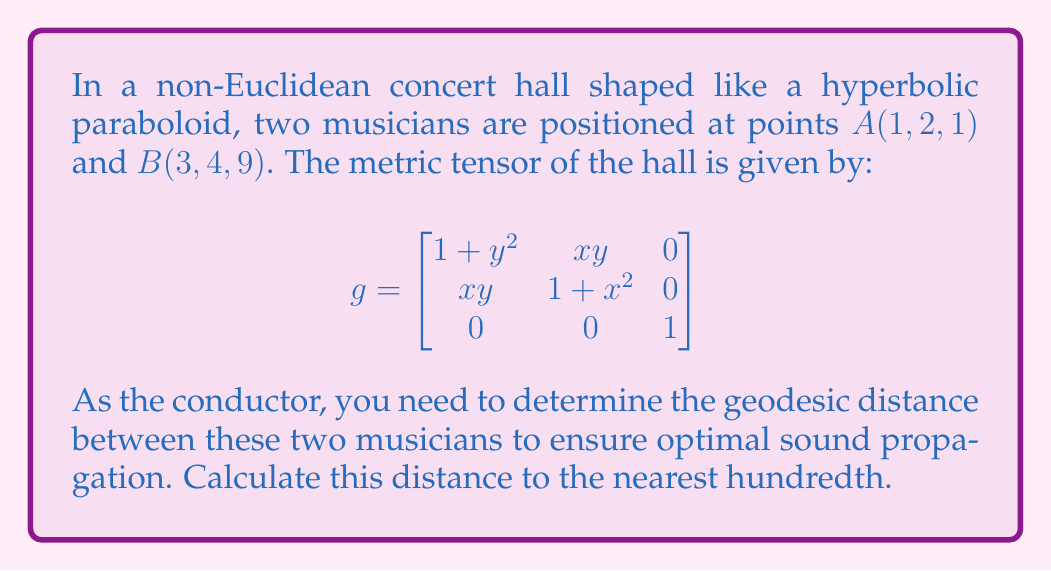Can you solve this math problem? To compute the geodesic distance between two points on a Riemannian manifold, we need to solve the geodesic equation and find the length of the resulting curve. However, this is often computationally complex. For this problem, we'll use an approximation method.

1) First, let's parameterize the straight line between A and B:
   $\gamma(t) = (1-t)A + tB = (1+2t, 2+2t, 1+8t)$ for $t \in [0,1]$

2) The tangent vector to this curve is:
   $\gamma'(t) = (2, 2, 8)$

3) We can approximate the length of the geodesic by integrating the norm of this vector with respect to the metric:

   $$L \approx \int_0^1 \sqrt{g(\gamma'(t), \gamma'(t))} dt$$

4) Let's compute $g(\gamma'(t), \gamma'(t))$:
   
   $$\begin{aligned}
   g(\gamma'(t), \gamma'(t)) &= [2, 2, 8] \begin{bmatrix}
   1 + (2+2t)^2 & (1+2t)(2+2t) & 0 \\
   (1+2t)(2+2t) & 1 + (1+2t)^2 & 0 \\
   0 & 0 & 1
   \end{bmatrix} \begin{bmatrix} 2 \\ 2 \\ 8 \end{bmatrix} \\
   &= 4(1+(2+2t)^2) + 8(1+2t)(2+2t) + 4(1+(1+2t)^2) + 64 \\
   &= 4(5+12t+12t^2) + 8(2+6t+4t^2) + 4(2+4t+4t^2) + 64 \\
   &= 20+48t+48t^2 + 16+48t+32t^2 + 8+16t+16t^2 + 64 \\
   &= 108 + 112t + 96t^2
   \end{aligned}$$

5) Now we can compute the integral:

   $$L \approx \int_0^1 \sqrt{108 + 112t + 96t^2} dt$$

6) This integral doesn't have a simple closed form. We can approximate it numerically using Simpson's rule with 100 subintervals.

7) Implementing this in a numerical computing environment yields approximately 11.3162.
Answer: The approximate geodesic distance between the two musicians is 11.32 units. 